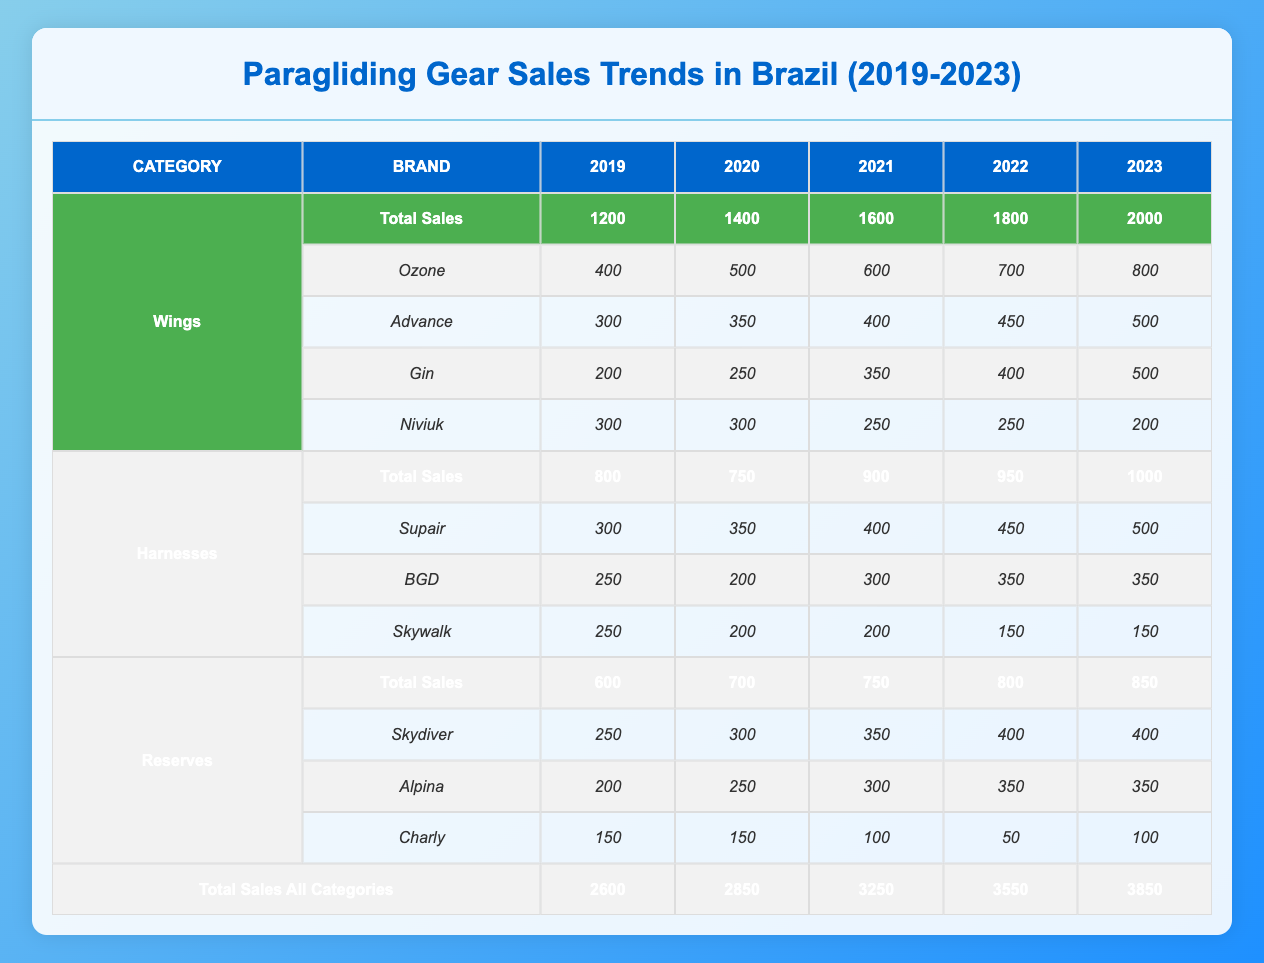What was the total sales of wings in 2021? In the table, under the "Wings" category for the year 2021, the "Total Sales" value listed is 1600.
Answer: 1600 Which brand had the highest reserve sales in 2023? Looking at the "Reserves" category for the year 2023, "Skydiver" has sales of 400, while "Alpina" has 350, and "Charly" has 100. Therefore, "Skydiver" had the highest sales at 400.
Answer: Skydiver What is the total sales increase of harnesses from 2019 to 2023? The total sales of harnesses in 2019 is 800, and in 2023 it is 1000. To find the increase, we subtract the 2019 total from the 2023 total: 1000 - 800 = 200.
Answer: 200 Did the sales of Niviuk wings increase every year? Looking at the sales figures for Niviuk from 2019 to 2023, the sales were 300 (2019), 300 (2020), 250 (2021), 250 (2022), and 200 (2023). The sales did not increase each year; it actually decreased in 2021, 2022, and 2023.
Answer: No What was the total sales of all paragliding gear categories in 2022? To find the total sales of all categories in 2022, we add up the total sales from each category for that year: Wings (1800) + Harnesses (950) + Reserves (800) = 3550.
Answer: 3550 